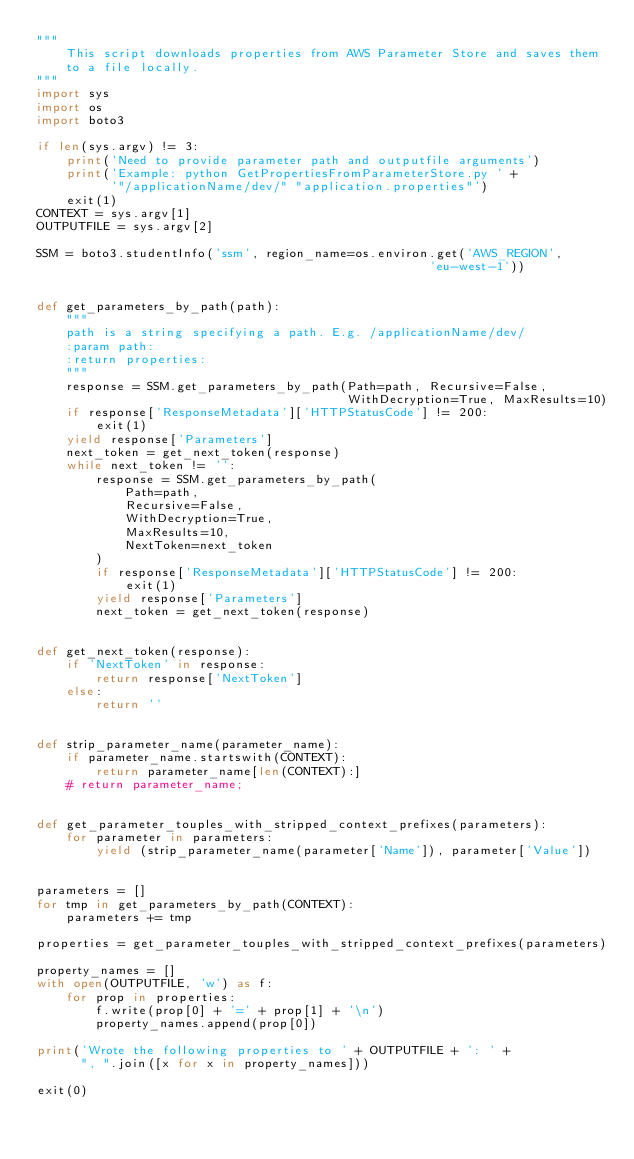Convert code to text. <code><loc_0><loc_0><loc_500><loc_500><_Python_>"""
    This script downloads properties from AWS Parameter Store and saves them
    to a file locally.
"""
import sys
import os
import boto3

if len(sys.argv) != 3:
    print('Need to provide parameter path and outputfile arguments')
    print('Example: python GetPropertiesFromParameterStore.py ' +
          '"/applicationName/dev/" "application.properties"')
    exit(1)
CONTEXT = sys.argv[1]
OUTPUTFILE = sys.argv[2]

SSM = boto3.studentInfo('ssm', region_name=os.environ.get('AWS_REGION',
                                                     'eu-west-1'))


def get_parameters_by_path(path):
    """
    path is a string specifying a path. E.g. /applicationName/dev/
    :param path:
    :return properties:
    """
    response = SSM.get_parameters_by_path(Path=path, Recursive=False,
                                          WithDecryption=True, MaxResults=10)
    if response['ResponseMetadata']['HTTPStatusCode'] != 200:
        exit(1)
    yield response['Parameters']
    next_token = get_next_token(response)
    while next_token != '':
        response = SSM.get_parameters_by_path(
            Path=path,
            Recursive=False,
            WithDecryption=True,
            MaxResults=10,
            NextToken=next_token
        )
        if response['ResponseMetadata']['HTTPStatusCode'] != 200:
            exit(1)
        yield response['Parameters']
        next_token = get_next_token(response)


def get_next_token(response):
    if 'NextToken' in response:
        return response['NextToken']
    else:
        return ''


def strip_parameter_name(parameter_name):
    if parameter_name.startswith(CONTEXT):
        return parameter_name[len(CONTEXT):]
    # return parameter_name;


def get_parameter_touples_with_stripped_context_prefixes(parameters):
    for parameter in parameters:
        yield (strip_parameter_name(parameter['Name']), parameter['Value'])


parameters = []
for tmp in get_parameters_by_path(CONTEXT):
    parameters += tmp

properties = get_parameter_touples_with_stripped_context_prefixes(parameters)

property_names = []
with open(OUTPUTFILE, 'w') as f:
    for prop in properties:
        f.write(prop[0] + '=' + prop[1] + '\n')
        property_names.append(prop[0])

print('Wrote the following properties to ' + OUTPUTFILE + ': ' +
      ", ".join([x for x in property_names]))

exit(0)
</code> 